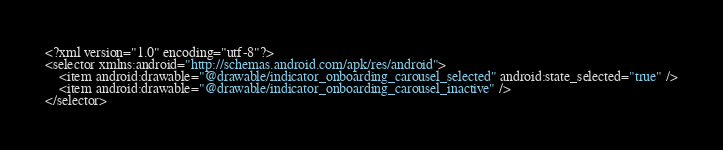Convert code to text. <code><loc_0><loc_0><loc_500><loc_500><_XML_><?xml version="1.0" encoding="utf-8"?>
<selector xmlns:android="http://schemas.android.com/apk/res/android">
    <item android:drawable="@drawable/indicator_onboarding_carousel_selected" android:state_selected="true" />
    <item android:drawable="@drawable/indicator_onboarding_carousel_inactive" />
</selector></code> 